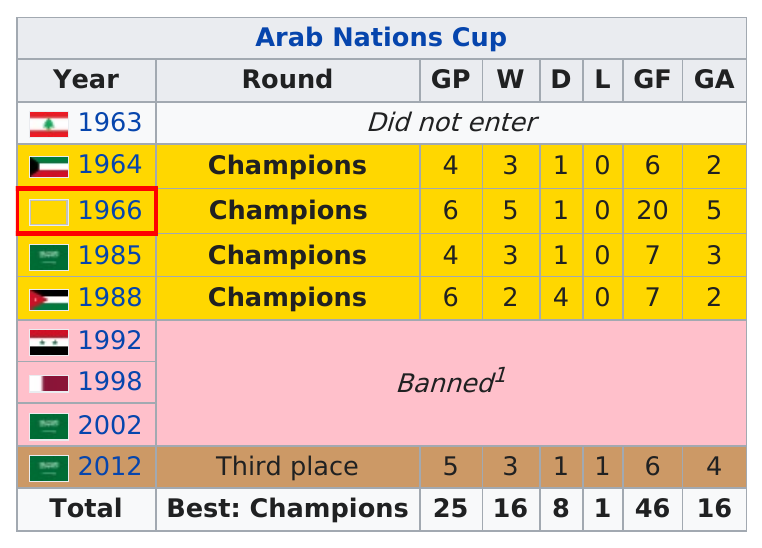Identify some key points in this picture. The largest GF in team history in the Arab Nations Cup was achieved in 2020 with a score of 20. For a period of 10 years, the team was banned from participating in the Arab Nations Cup. The team won at least 5 games a total of [X] times in the Arab Nations Cup. 